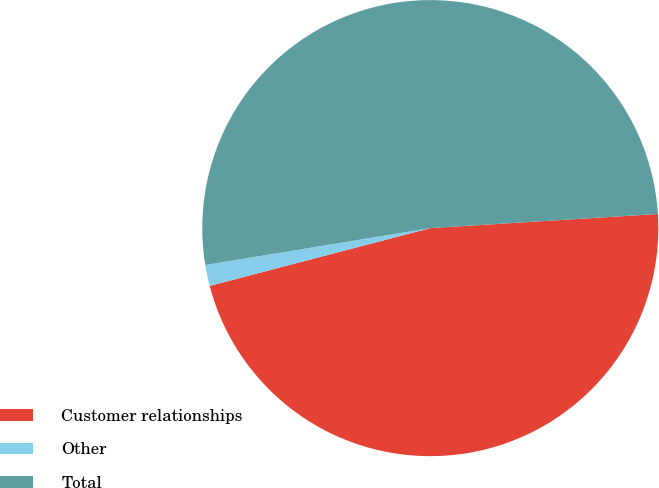Convert chart to OTSL. <chart><loc_0><loc_0><loc_500><loc_500><pie_chart><fcel>Customer relationships<fcel>Other<fcel>Total<nl><fcel>46.91%<fcel>1.49%<fcel>51.6%<nl></chart> 